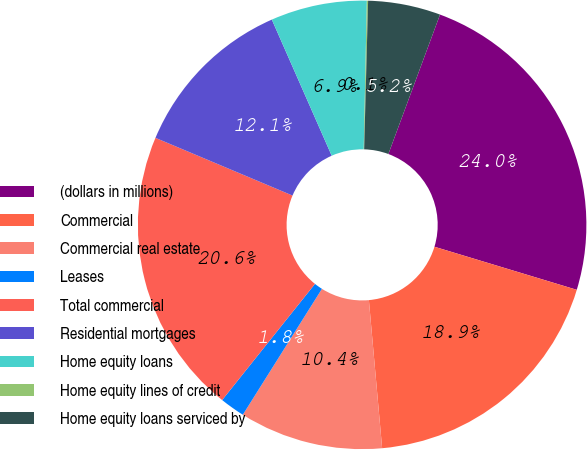Convert chart. <chart><loc_0><loc_0><loc_500><loc_500><pie_chart><fcel>(dollars in millions)<fcel>Commercial<fcel>Commercial real estate<fcel>Leases<fcel>Total commercial<fcel>Residential mortgages<fcel>Home equity loans<fcel>Home equity lines of credit<fcel>Home equity loans serviced by<nl><fcel>24.03%<fcel>18.9%<fcel>10.35%<fcel>1.8%<fcel>20.61%<fcel>12.06%<fcel>6.93%<fcel>0.09%<fcel>5.22%<nl></chart> 